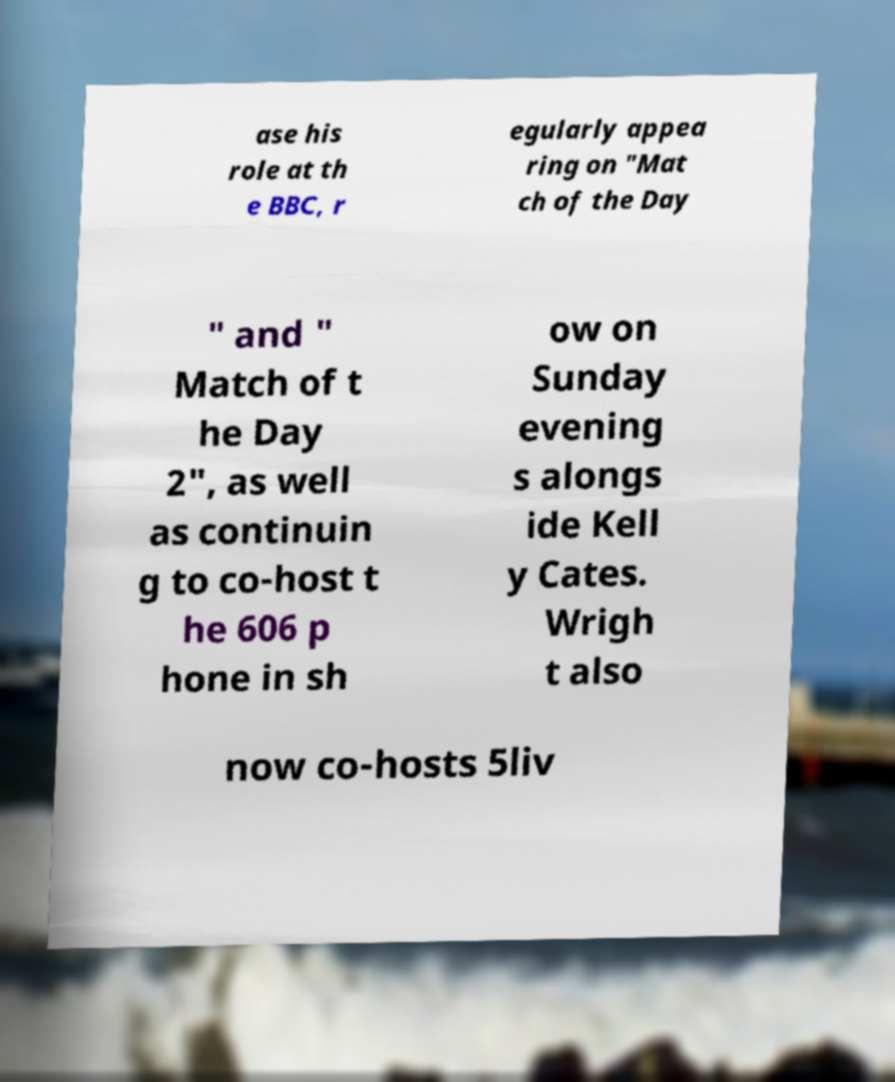Can you accurately transcribe the text from the provided image for me? ase his role at th e BBC, r egularly appea ring on "Mat ch of the Day " and " Match of t he Day 2", as well as continuin g to co-host t he 606 p hone in sh ow on Sunday evening s alongs ide Kell y Cates. Wrigh t also now co-hosts 5liv 